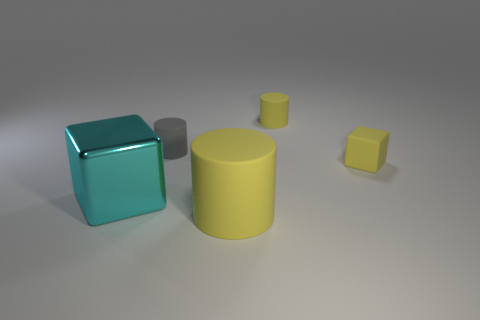Is there any other thing that has the same material as the big cyan thing?
Offer a very short reply. No. The other large object that is the same material as the gray thing is what color?
Keep it short and to the point. Yellow. What number of cylinders are the same size as the cyan thing?
Your answer should be compact. 1. There is a yellow cylinder that is behind the cyan thing; is it the same size as the rubber block?
Provide a succinct answer. Yes. The yellow rubber object that is both in front of the gray object and behind the big cyan object has what shape?
Your answer should be very brief. Cube. Are there any small yellow matte cubes right of the metallic thing?
Make the answer very short. Yes. Is there any other thing that is the same shape as the large yellow thing?
Your answer should be very brief. Yes. Do the big yellow matte thing and the gray object have the same shape?
Offer a terse response. Yes. Are there the same number of large cyan things that are left of the metal thing and large matte cylinders behind the big yellow matte cylinder?
Offer a very short reply. Yes. How many other things are there of the same material as the large block?
Provide a succinct answer. 0. 